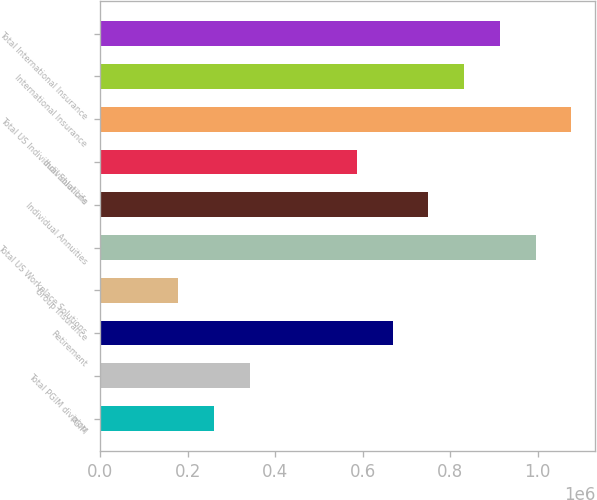Convert chart to OTSL. <chart><loc_0><loc_0><loc_500><loc_500><bar_chart><fcel>PGIM<fcel>Total PGIM division<fcel>Retirement<fcel>Group Insurance<fcel>Total US Workplace Solutions<fcel>Individual Annuities<fcel>Individual Life<fcel>Total US Individual Solutions<fcel>International Insurance<fcel>Total International Insurance<nl><fcel>259830<fcel>341588<fcel>668620<fcel>178072<fcel>995652<fcel>750378<fcel>586862<fcel>1.07741e+06<fcel>832136<fcel>913894<nl></chart> 